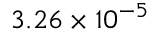Convert formula to latex. <formula><loc_0><loc_0><loc_500><loc_500>3 . 2 6 \times 1 0 ^ { - 5 }</formula> 